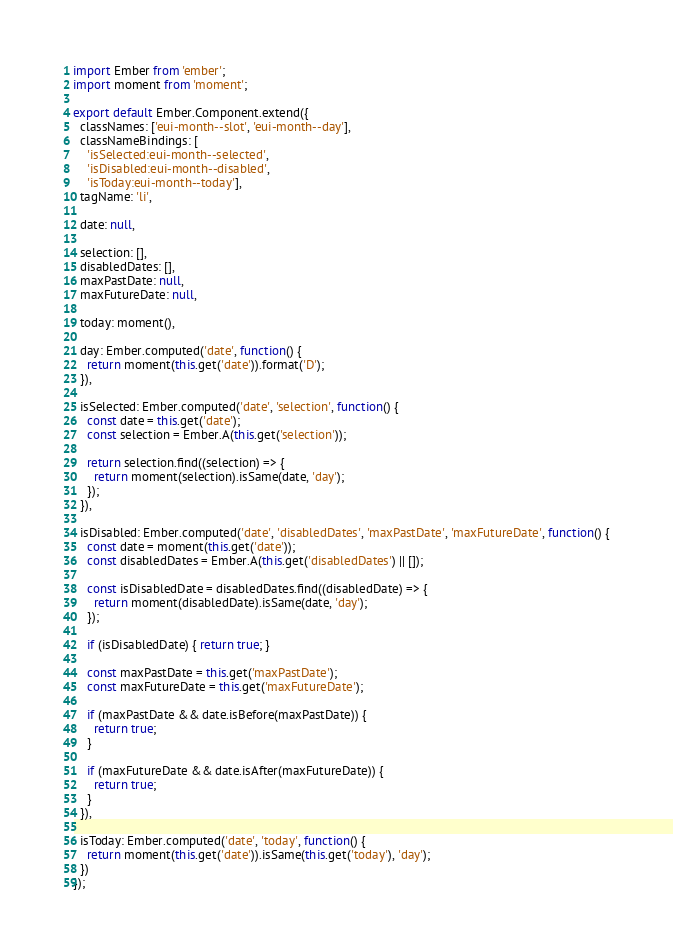<code> <loc_0><loc_0><loc_500><loc_500><_JavaScript_>import Ember from 'ember';
import moment from 'moment';

export default Ember.Component.extend({
  classNames: ['eui-month--slot', 'eui-month--day'],
  classNameBindings: [
    'isSelected:eui-month--selected',
    'isDisabled:eui-month--disabled',
    'isToday:eui-month--today'],
  tagName: 'li',

  date: null,

  selection: [],
  disabledDates: [],
  maxPastDate: null,
  maxFutureDate: null,

  today: moment(),

  day: Ember.computed('date', function() {
    return moment(this.get('date')).format('D');
  }),

  isSelected: Ember.computed('date', 'selection', function() {
    const date = this.get('date');
    const selection = Ember.A(this.get('selection'));

    return selection.find((selection) => {
      return moment(selection).isSame(date, 'day');
    });
  }),

  isDisabled: Ember.computed('date', 'disabledDates', 'maxPastDate', 'maxFutureDate', function() {
    const date = moment(this.get('date'));
    const disabledDates = Ember.A(this.get('disabledDates') || []);

    const isDisabledDate = disabledDates.find((disabledDate) => {
      return moment(disabledDate).isSame(date, 'day');
    });

    if (isDisabledDate) { return true; }

    const maxPastDate = this.get('maxPastDate');
    const maxFutureDate = this.get('maxFutureDate');

    if (maxPastDate && date.isBefore(maxPastDate)) {
      return true;
    }

    if (maxFutureDate && date.isAfter(maxFutureDate)) {
      return true;
    }
  }),

  isToday: Ember.computed('date', 'today', function() {
    return moment(this.get('date')).isSame(this.get('today'), 'day');
  })
});
</code> 